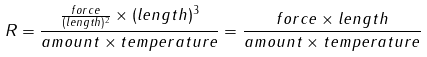<formula> <loc_0><loc_0><loc_500><loc_500>R = { \frac { { \frac { f o r c e } { ( l e n g t h ) ^ { 2 } } } \times ( l e n g t h ) ^ { 3 } } { a m o u n t \times t e m p e r a t u r e } } = { \frac { f o r c e \times l e n g t h } { a m o u n t \times t e m p e r a t u r e } }</formula> 